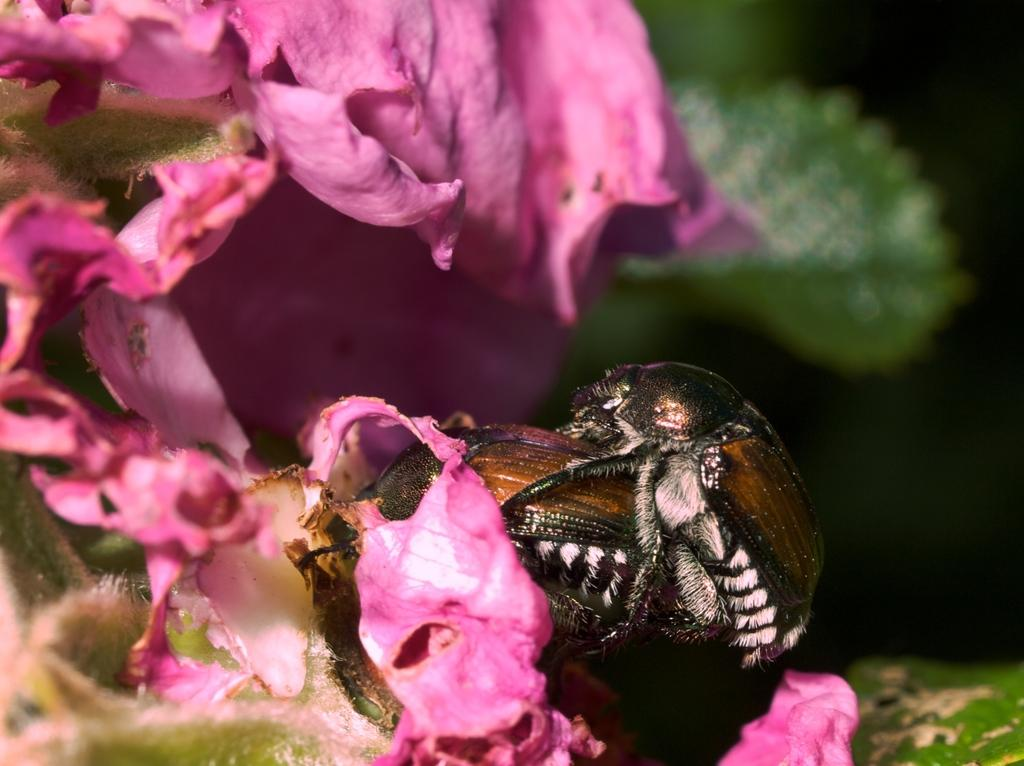What is happening between the insects in the image? There is an insect on another insect in the image. Where are the insects located? The insects are on a plant. What can be seen on the left side of the image? There are flowers on the left side of the image. What is the condition of the background in the image? The background of the image is blurred. What type of vegetation is visible in the background? Leaves are visible in the background of the image. What type of shock can be seen affecting the insects in the image? There is no shock present in the image; it features insects on a plant. How many light bulbs are visible in the image? There are no light bulbs present in the image. 